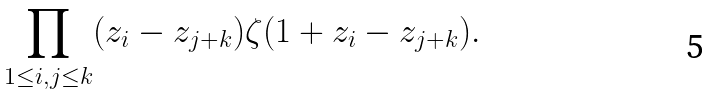Convert formula to latex. <formula><loc_0><loc_0><loc_500><loc_500>\prod _ { 1 \leq i , j \leq k } ( z _ { i } - z _ { j + k } ) \zeta ( 1 + z _ { i } - z _ { j + k } ) .</formula> 